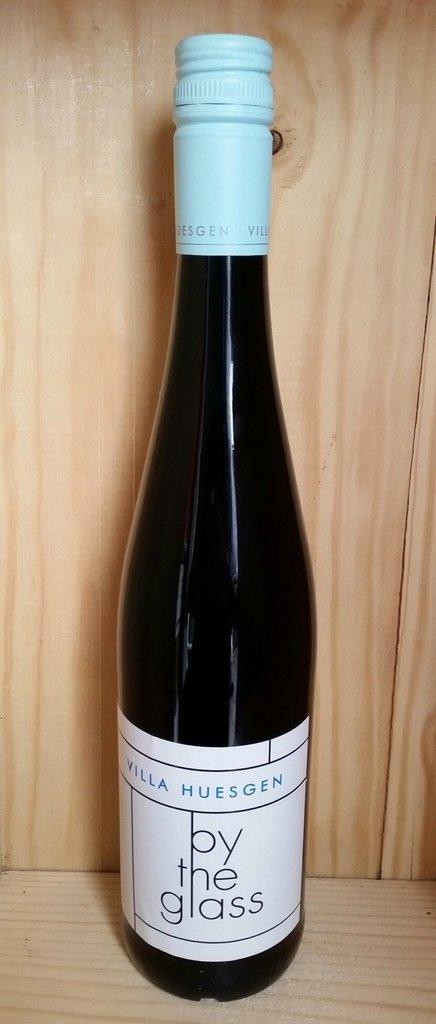What is the name of the drink?
Give a very brief answer. By the glass. Who's name is on this wine?
Provide a succinct answer. By the glass. 